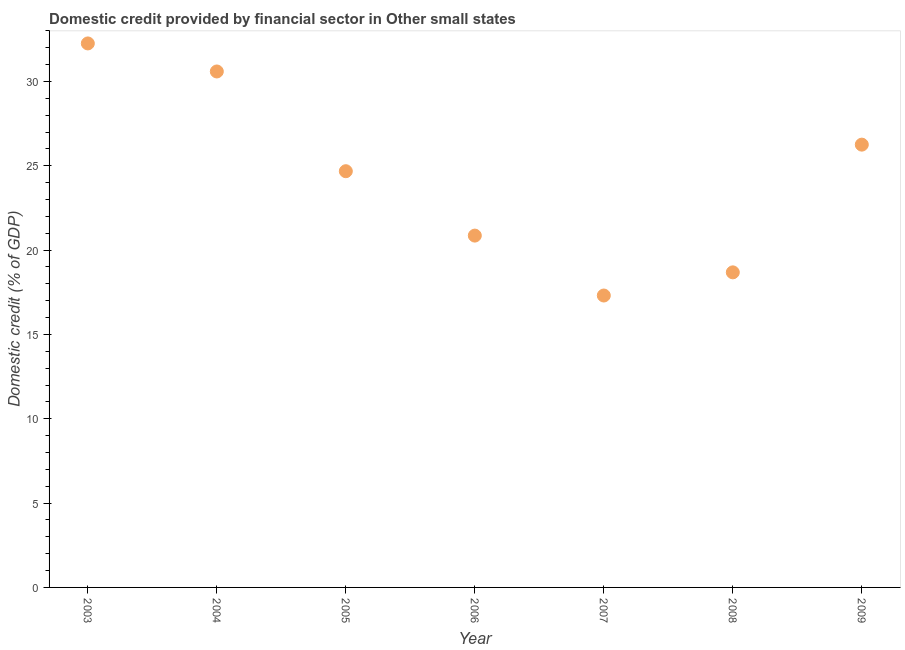What is the domestic credit provided by financial sector in 2003?
Your response must be concise. 32.26. Across all years, what is the maximum domestic credit provided by financial sector?
Give a very brief answer. 32.26. Across all years, what is the minimum domestic credit provided by financial sector?
Give a very brief answer. 17.31. In which year was the domestic credit provided by financial sector maximum?
Provide a succinct answer. 2003. In which year was the domestic credit provided by financial sector minimum?
Your response must be concise. 2007. What is the sum of the domestic credit provided by financial sector?
Make the answer very short. 170.63. What is the difference between the domestic credit provided by financial sector in 2003 and 2007?
Provide a short and direct response. 14.95. What is the average domestic credit provided by financial sector per year?
Keep it short and to the point. 24.38. What is the median domestic credit provided by financial sector?
Ensure brevity in your answer.  24.68. Do a majority of the years between 2006 and 2004 (inclusive) have domestic credit provided by financial sector greater than 12 %?
Ensure brevity in your answer.  No. What is the ratio of the domestic credit provided by financial sector in 2008 to that in 2009?
Ensure brevity in your answer.  0.71. Is the domestic credit provided by financial sector in 2004 less than that in 2009?
Provide a succinct answer. No. Is the difference between the domestic credit provided by financial sector in 2004 and 2007 greater than the difference between any two years?
Ensure brevity in your answer.  No. What is the difference between the highest and the second highest domestic credit provided by financial sector?
Keep it short and to the point. 1.66. What is the difference between the highest and the lowest domestic credit provided by financial sector?
Ensure brevity in your answer.  14.95. How many dotlines are there?
Provide a short and direct response. 1. How many years are there in the graph?
Keep it short and to the point. 7. What is the difference between two consecutive major ticks on the Y-axis?
Offer a terse response. 5. Does the graph contain any zero values?
Your answer should be very brief. No. Does the graph contain grids?
Make the answer very short. No. What is the title of the graph?
Your answer should be compact. Domestic credit provided by financial sector in Other small states. What is the label or title of the X-axis?
Give a very brief answer. Year. What is the label or title of the Y-axis?
Your answer should be compact. Domestic credit (% of GDP). What is the Domestic credit (% of GDP) in 2003?
Your response must be concise. 32.26. What is the Domestic credit (% of GDP) in 2004?
Provide a succinct answer. 30.59. What is the Domestic credit (% of GDP) in 2005?
Offer a very short reply. 24.68. What is the Domestic credit (% of GDP) in 2006?
Offer a terse response. 20.86. What is the Domestic credit (% of GDP) in 2007?
Offer a terse response. 17.31. What is the Domestic credit (% of GDP) in 2008?
Keep it short and to the point. 18.68. What is the Domestic credit (% of GDP) in 2009?
Provide a succinct answer. 26.25. What is the difference between the Domestic credit (% of GDP) in 2003 and 2004?
Your answer should be very brief. 1.66. What is the difference between the Domestic credit (% of GDP) in 2003 and 2005?
Ensure brevity in your answer.  7.58. What is the difference between the Domestic credit (% of GDP) in 2003 and 2006?
Make the answer very short. 11.39. What is the difference between the Domestic credit (% of GDP) in 2003 and 2007?
Make the answer very short. 14.95. What is the difference between the Domestic credit (% of GDP) in 2003 and 2008?
Ensure brevity in your answer.  13.57. What is the difference between the Domestic credit (% of GDP) in 2003 and 2009?
Provide a succinct answer. 6. What is the difference between the Domestic credit (% of GDP) in 2004 and 2005?
Keep it short and to the point. 5.91. What is the difference between the Domestic credit (% of GDP) in 2004 and 2006?
Make the answer very short. 9.73. What is the difference between the Domestic credit (% of GDP) in 2004 and 2007?
Your answer should be very brief. 13.28. What is the difference between the Domestic credit (% of GDP) in 2004 and 2008?
Make the answer very short. 11.91. What is the difference between the Domestic credit (% of GDP) in 2004 and 2009?
Make the answer very short. 4.34. What is the difference between the Domestic credit (% of GDP) in 2005 and 2006?
Provide a short and direct response. 3.82. What is the difference between the Domestic credit (% of GDP) in 2005 and 2007?
Keep it short and to the point. 7.37. What is the difference between the Domestic credit (% of GDP) in 2005 and 2008?
Provide a succinct answer. 6. What is the difference between the Domestic credit (% of GDP) in 2005 and 2009?
Ensure brevity in your answer.  -1.58. What is the difference between the Domestic credit (% of GDP) in 2006 and 2007?
Ensure brevity in your answer.  3.55. What is the difference between the Domestic credit (% of GDP) in 2006 and 2008?
Keep it short and to the point. 2.18. What is the difference between the Domestic credit (% of GDP) in 2006 and 2009?
Make the answer very short. -5.39. What is the difference between the Domestic credit (% of GDP) in 2007 and 2008?
Your response must be concise. -1.37. What is the difference between the Domestic credit (% of GDP) in 2007 and 2009?
Provide a short and direct response. -8.95. What is the difference between the Domestic credit (% of GDP) in 2008 and 2009?
Offer a very short reply. -7.57. What is the ratio of the Domestic credit (% of GDP) in 2003 to that in 2004?
Your answer should be compact. 1.05. What is the ratio of the Domestic credit (% of GDP) in 2003 to that in 2005?
Make the answer very short. 1.31. What is the ratio of the Domestic credit (% of GDP) in 2003 to that in 2006?
Offer a very short reply. 1.55. What is the ratio of the Domestic credit (% of GDP) in 2003 to that in 2007?
Ensure brevity in your answer.  1.86. What is the ratio of the Domestic credit (% of GDP) in 2003 to that in 2008?
Your response must be concise. 1.73. What is the ratio of the Domestic credit (% of GDP) in 2003 to that in 2009?
Provide a short and direct response. 1.23. What is the ratio of the Domestic credit (% of GDP) in 2004 to that in 2005?
Keep it short and to the point. 1.24. What is the ratio of the Domestic credit (% of GDP) in 2004 to that in 2006?
Your answer should be very brief. 1.47. What is the ratio of the Domestic credit (% of GDP) in 2004 to that in 2007?
Provide a short and direct response. 1.77. What is the ratio of the Domestic credit (% of GDP) in 2004 to that in 2008?
Keep it short and to the point. 1.64. What is the ratio of the Domestic credit (% of GDP) in 2004 to that in 2009?
Your response must be concise. 1.17. What is the ratio of the Domestic credit (% of GDP) in 2005 to that in 2006?
Offer a terse response. 1.18. What is the ratio of the Domestic credit (% of GDP) in 2005 to that in 2007?
Your answer should be compact. 1.43. What is the ratio of the Domestic credit (% of GDP) in 2005 to that in 2008?
Provide a succinct answer. 1.32. What is the ratio of the Domestic credit (% of GDP) in 2006 to that in 2007?
Ensure brevity in your answer.  1.21. What is the ratio of the Domestic credit (% of GDP) in 2006 to that in 2008?
Your answer should be compact. 1.12. What is the ratio of the Domestic credit (% of GDP) in 2006 to that in 2009?
Keep it short and to the point. 0.8. What is the ratio of the Domestic credit (% of GDP) in 2007 to that in 2008?
Your answer should be compact. 0.93. What is the ratio of the Domestic credit (% of GDP) in 2007 to that in 2009?
Offer a very short reply. 0.66. What is the ratio of the Domestic credit (% of GDP) in 2008 to that in 2009?
Make the answer very short. 0.71. 